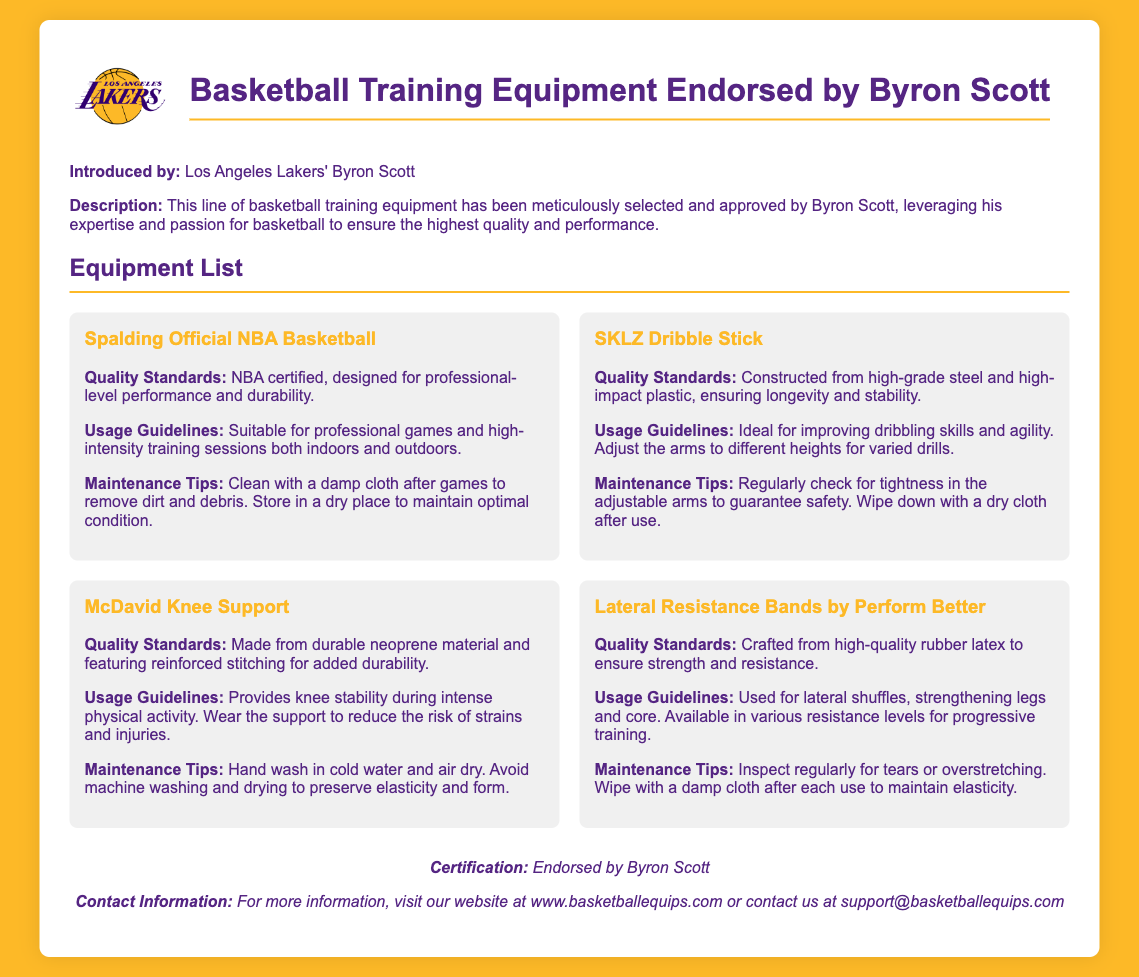What brand is the official basketball? The document lists the Spalding brand as the official basketball endorsed by Byron Scott.
Answer: Spalding What material is the SKLZ Dribble Stick made from? The SKLZ Dribble Stick is constructed from high-grade steel and high-impact plastic, as stated in the quality standards section of the document.
Answer: High-grade steel and high-impact plastic What feature does the McDavid Knee Support offer? The document indicates that the McDavid Knee Support provides knee stability during intense physical activity.
Answer: Knee stability What type of material are the Lateral Resistance Bands made from? The document specifies that the Lateral Resistance Bands are crafted from high-quality rubber latex.
Answer: Rubber latex How should the McDavid Knee Support be washed? The maintenance tips indicate that the McDavid Knee Support should be hand washed in cold water.
Answer: Hand wash in cold water Why is it important to inspect the Lateral Resistance Bands regularly? The document mentions inspecting the Lateral Resistance Bands regularly for tears or overstretching to maintain their integrity.
Answer: To check for tears or overstretching What overall quality standard applies to the equipment endorsed by Byron Scott? The document states that all equipment has high-quality standards, specifically mentioning durability in the context of basketball training.
Answer: High-quality standards Where can one find more information about the equipment? The document provides a website link for more information about the basketball training equipment.
Answer: www.basketballequips.com 